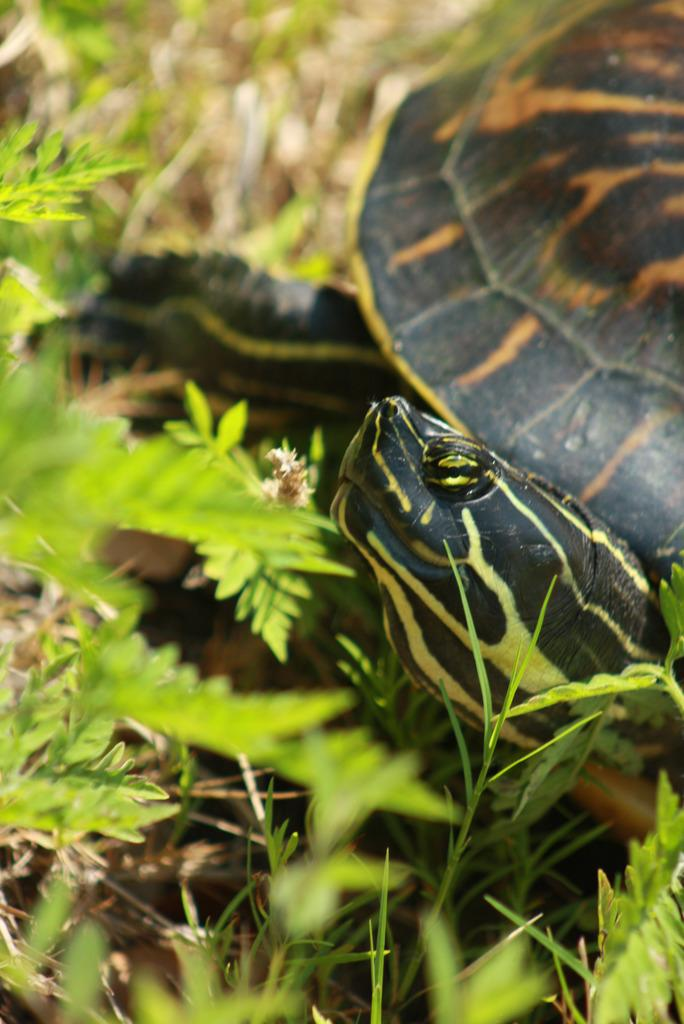What type of living organisms can be seen in the image? Plants and a tortoise can be seen in the image. Can you describe the tortoise in the image? The tortoise in the image is likely a pet or a resident of the environment where the image was taken. What type of bottle can be seen in the image? There is no bottle present in the image. Can you tell me how many planes are visible in the image? There are no planes visible in the image. 